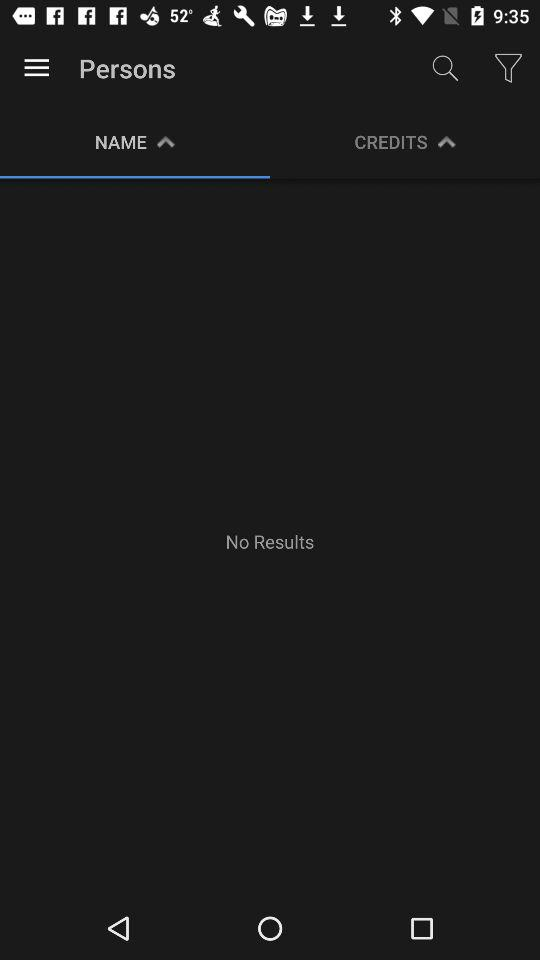Which tab is selected? The selected tab is "NAME". 